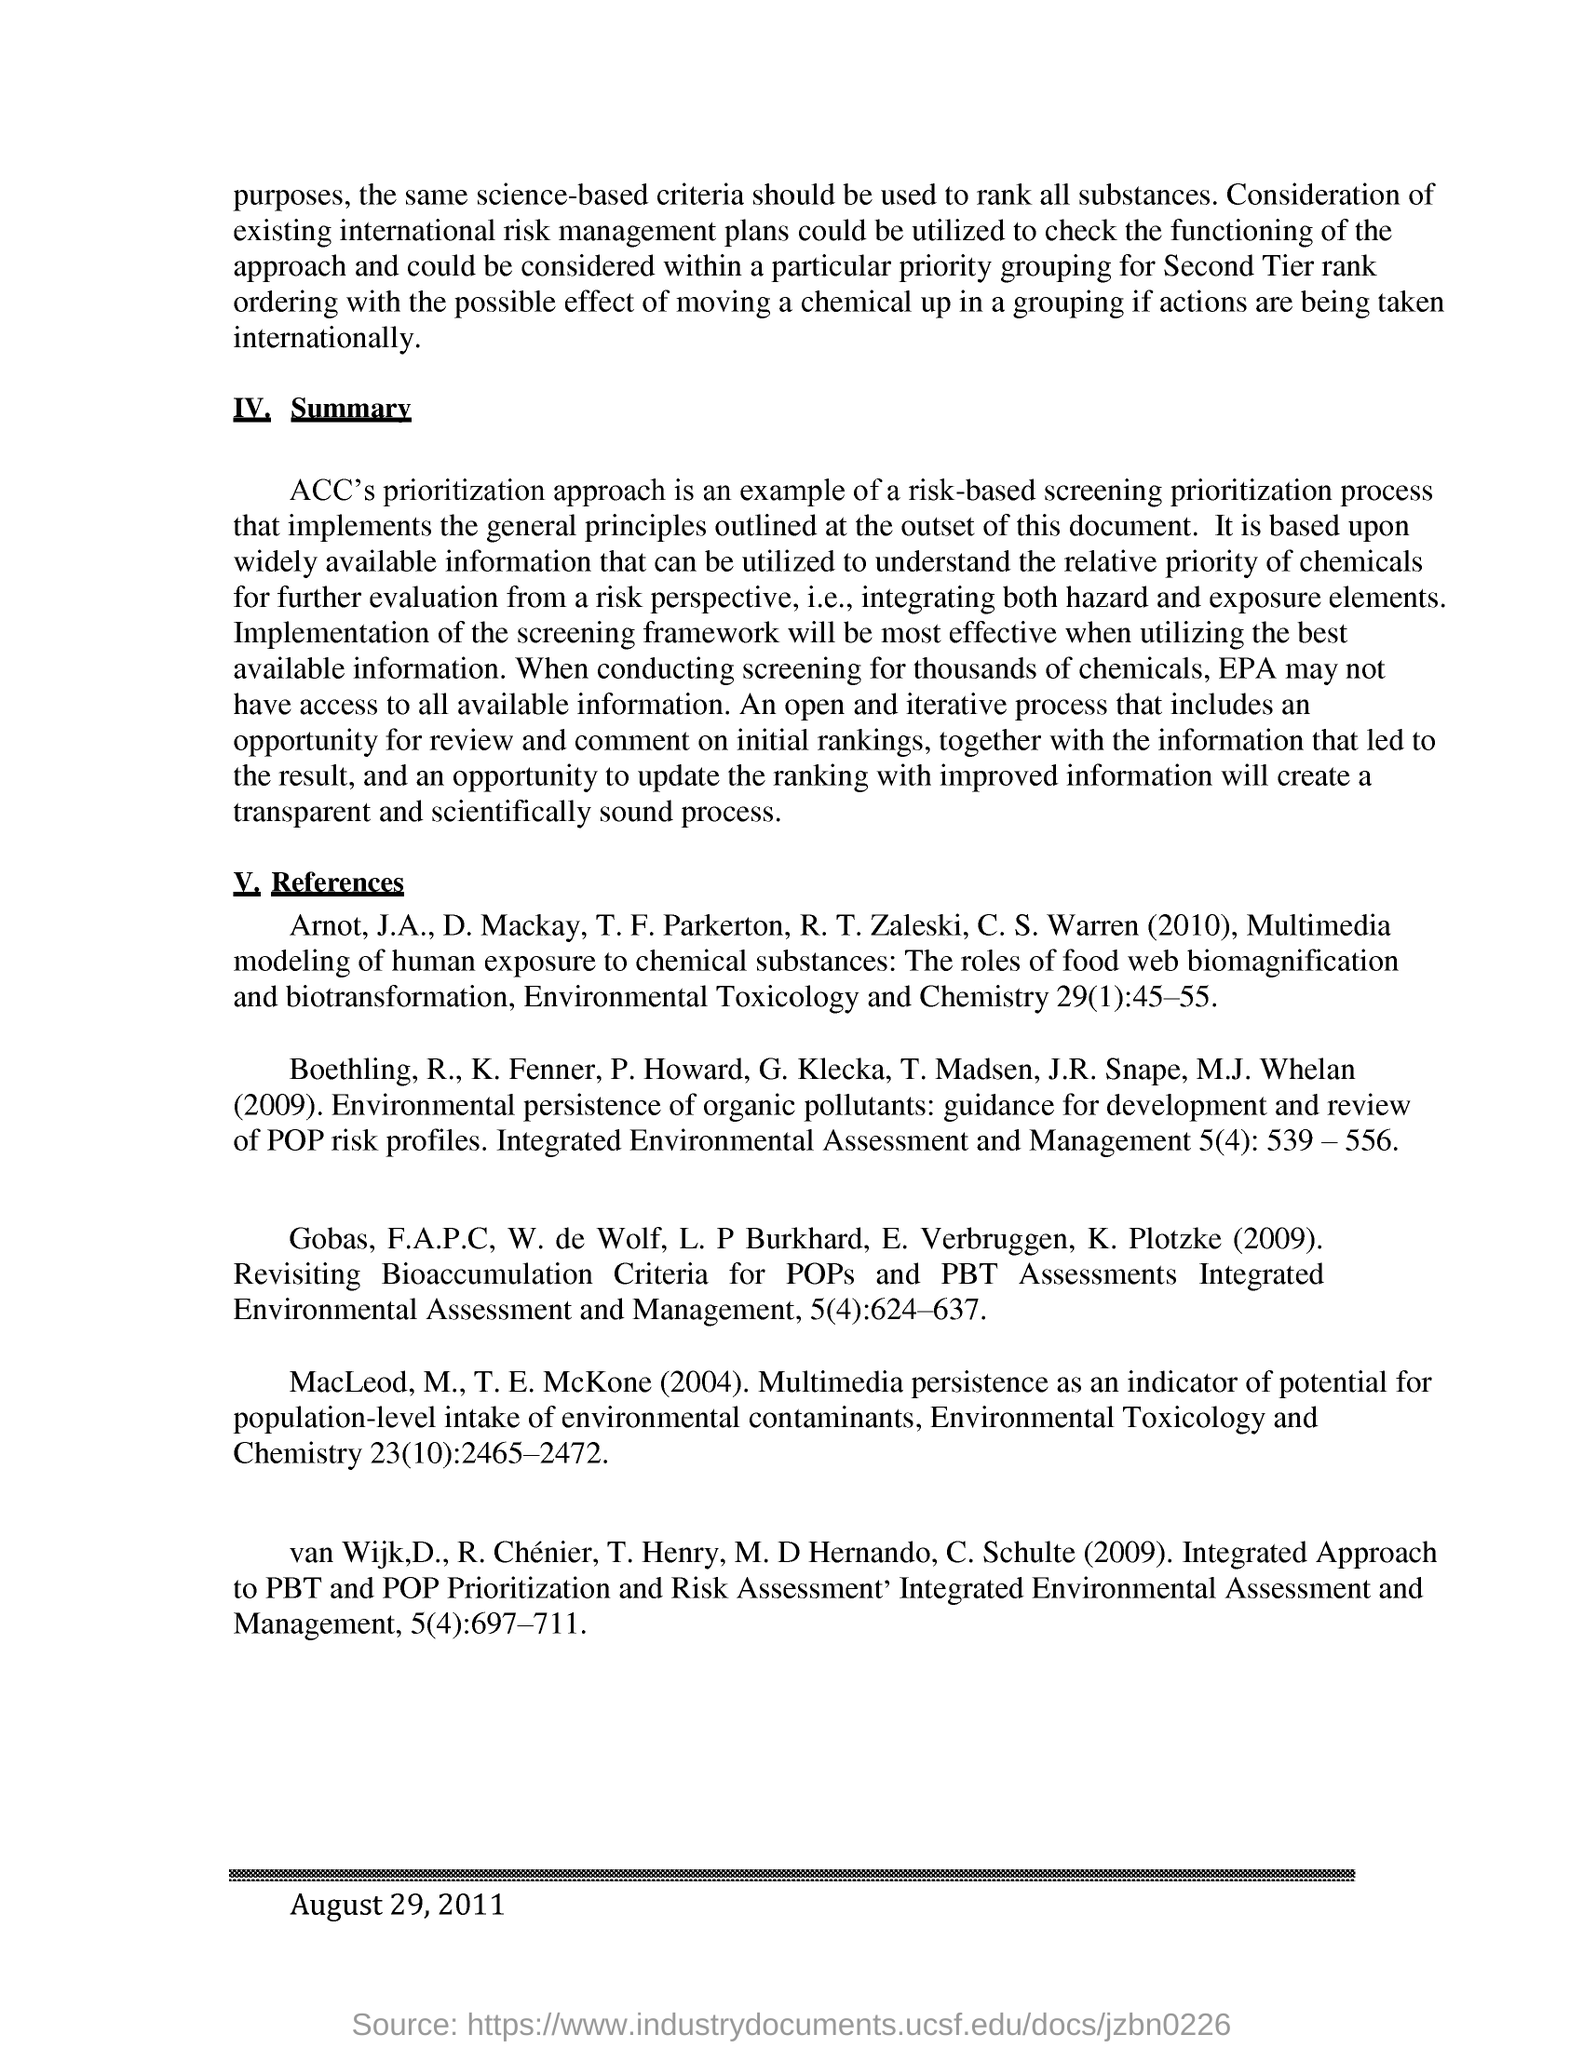List a handful of essential elements in this visual. The information was published on August 29, 2011. Despite screening for thousands of chemicals, the Environmental Protection Agency may not have access to all available information. The risk-based screening prioritization process used by ACC involves prioritizing accounts based on a combination of risk score and other factors, such as the likelihood of fraud and the value of the account, using ACC's proprietary prioritization approach. 